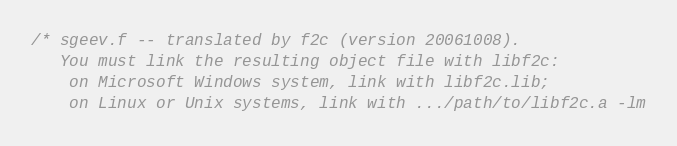<code> <loc_0><loc_0><loc_500><loc_500><_C_>/* sgeev.f -- translated by f2c (version 20061008).
   You must link the resulting object file with libf2c:
	on Microsoft Windows system, link with libf2c.lib;
	on Linux or Unix systems, link with .../path/to/libf2c.a -lm</code> 